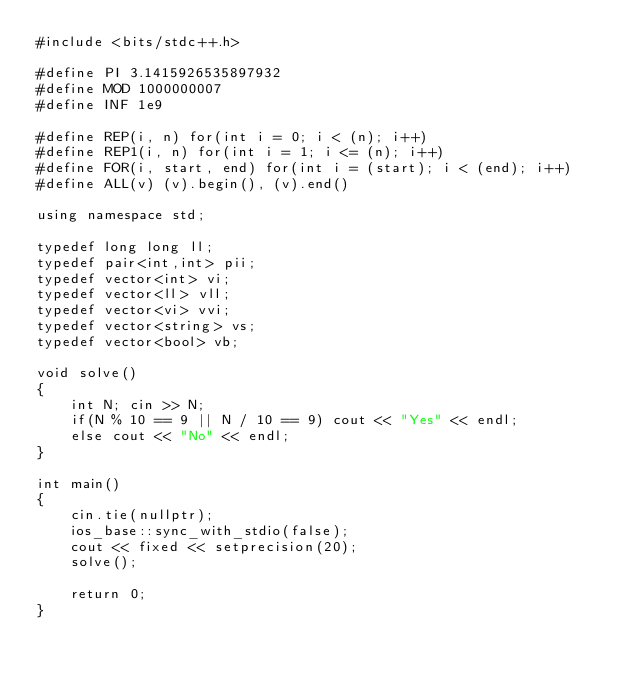Convert code to text. <code><loc_0><loc_0><loc_500><loc_500><_C++_>#include <bits/stdc++.h>

#define PI 3.1415926535897932
#define MOD 1000000007
#define INF 1e9

#define REP(i, n) for(int i = 0; i < (n); i++)
#define REP1(i, n) for(int i = 1; i <= (n); i++)
#define FOR(i, start, end) for(int i = (start); i < (end); i++)
#define ALL(v) (v).begin(), (v).end()

using namespace std;

typedef long long ll;
typedef pair<int,int> pii;
typedef vector<int> vi;
typedef vector<ll> vll;
typedef vector<vi> vvi;
typedef vector<string> vs;
typedef vector<bool> vb;

void solve()
{
    int N; cin >> N;
    if(N % 10 == 9 || N / 10 == 9) cout << "Yes" << endl;
    else cout << "No" << endl;
}

int main()
{
    cin.tie(nullptr);
    ios_base::sync_with_stdio(false);
    cout << fixed << setprecision(20);
    solve();

    return 0;
}</code> 